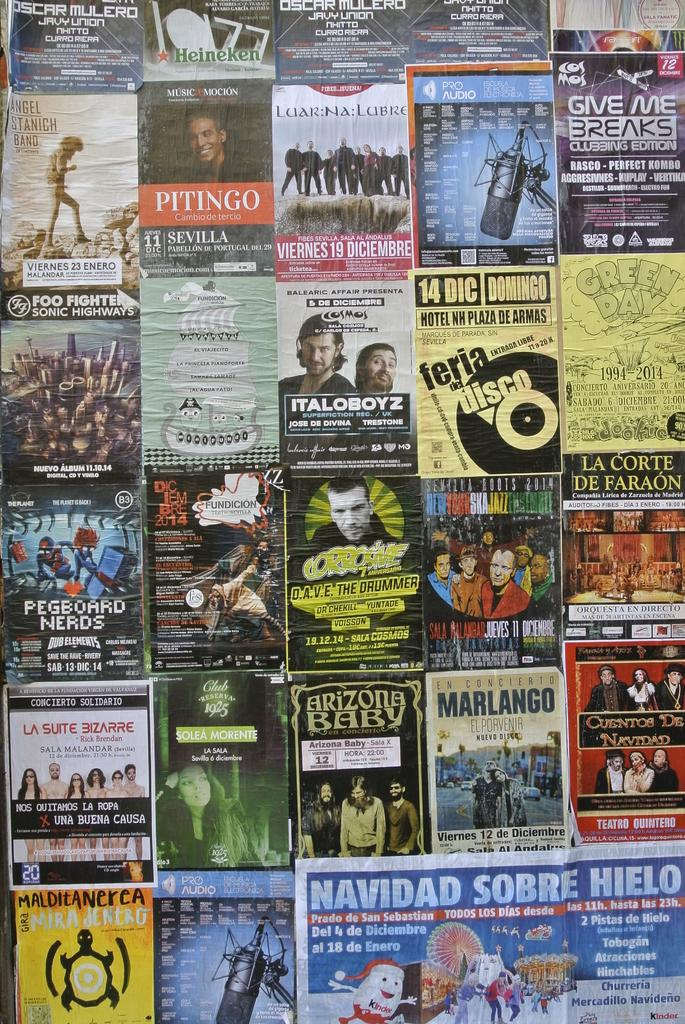Provide a one-sentence caption for the provided image. A poster for ITALOBOYZ is displayed on a while among many other posters. 